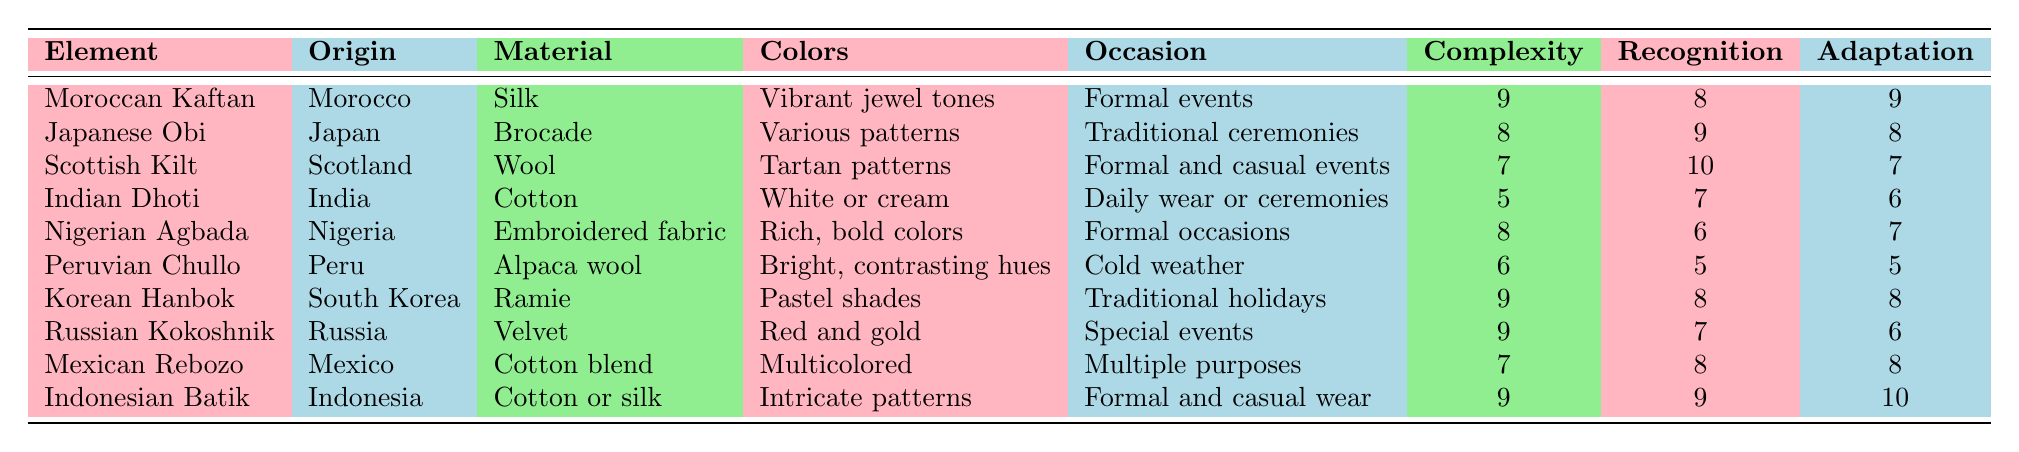What is the primary material used for the Japanese Obi? The table shows that the primary material for the Japanese Obi is Brocade.
Answer: Brocade Which traditional clothing element is recognized the most globally? Looking at the global recognition column, the Scottish Kilt has the highest score of 10, indicating it's the most recognized.
Answer: Scottish Kilt What are the typical colors of the Moroccan Kaftan? The table states that the Moroccan Kaftan displays vibrant jewel tones as typical colors.
Answer: Vibrant jewel tones Which elements have a design complexity of 9? By examining the design complexity values, the Moroccan Kaftan, Korean Hanbok, Russian Kokoshnik, and Indonesian Batik all have a complexity score of 9.
Answer: Moroccan Kaftan, Korean Hanbok, Russian Kokoshnik, Indonesian Batik What is the average design complexity of the traditional elements listed? The sum of design complexity values is 9 + 8 + 7 + 5 + 8 + 6 + 9 + 9 + 7 + 9 = 78. There are 10 elements, so the average is 78/10 = 7.8.
Answer: 7.8 Is the Peruvian Chullo suitable for formal occasions? The table indicates that the Peruvian Chullo is typically worn in cold weather, not for formal occasions. Therefore it is not suitable for formal occasions.
Answer: No Which element has the lowest potential for modern adaptation? The Peruvian Chullo has the lowest potential modern adaptation score of 5 according to the table.
Answer: Peruvian Chullo How does the recognition of the Indian Dhoti compare to that of the Moroccan Kaftan? The Indian Dhoti has a global recognition score of 7, whereas the Moroccan Kaftan has a score of 8. The Kaftan is recognized more than the Dhoti.
Answer: Moroccan Kaftan is more recognized Identify the traditional clothing worn for formal occasions with a design complexity higher than 7. The Nigerian Agbada (complexity 8), Moroccan Kaftan (complexity 9), Russian Kokoshnik (complexity 9), and Korean Hanbok (complexity 9) are all worn for formal occasions and have design complexity higher than 7.
Answer: Nigerian Agbada, Moroccan Kaftan, Russian Kokoshnik, Korean Hanbok Is there any traditional element that has the same recognition and adaptation score? By comparing the scores, the Mexican Rebozo has a recognition score of 8 and an adaptation score of 8, indicating that they are equal.
Answer: Yes, Mexican Rebozo 